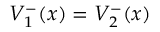<formula> <loc_0><loc_0><loc_500><loc_500>V _ { 1 } ^ { - } ( x ) = V _ { 2 } ^ { - } ( x )</formula> 